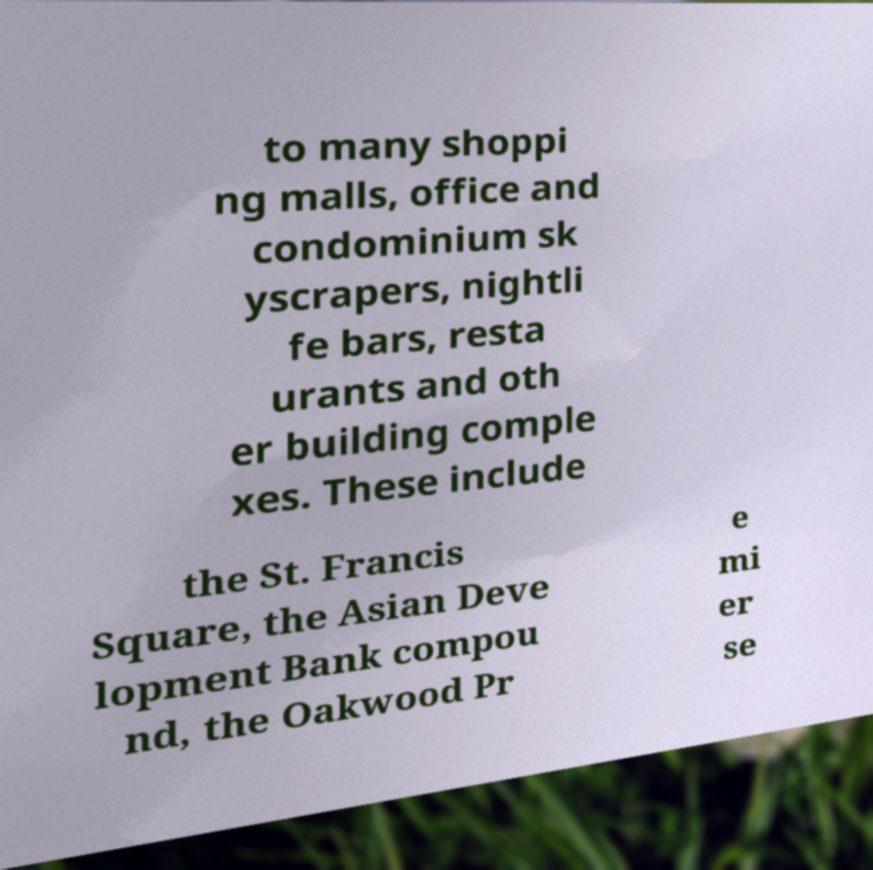There's text embedded in this image that I need extracted. Can you transcribe it verbatim? to many shoppi ng malls, office and condominium sk yscrapers, nightli fe bars, resta urants and oth er building comple xes. These include the St. Francis Square, the Asian Deve lopment Bank compou nd, the Oakwood Pr e mi er se 